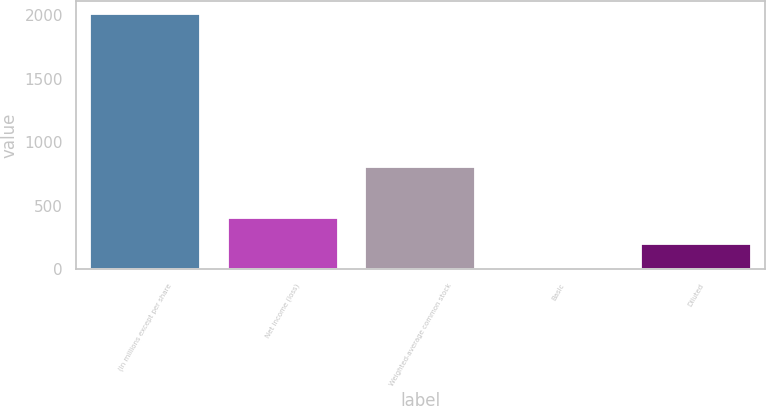Convert chart. <chart><loc_0><loc_0><loc_500><loc_500><bar_chart><fcel>(In millions except per share<fcel>Net income (loss)<fcel>Weighted-average common stock<fcel>Basic<fcel>Diluted<nl><fcel>2012<fcel>402.59<fcel>804.95<fcel>0.23<fcel>201.41<nl></chart> 